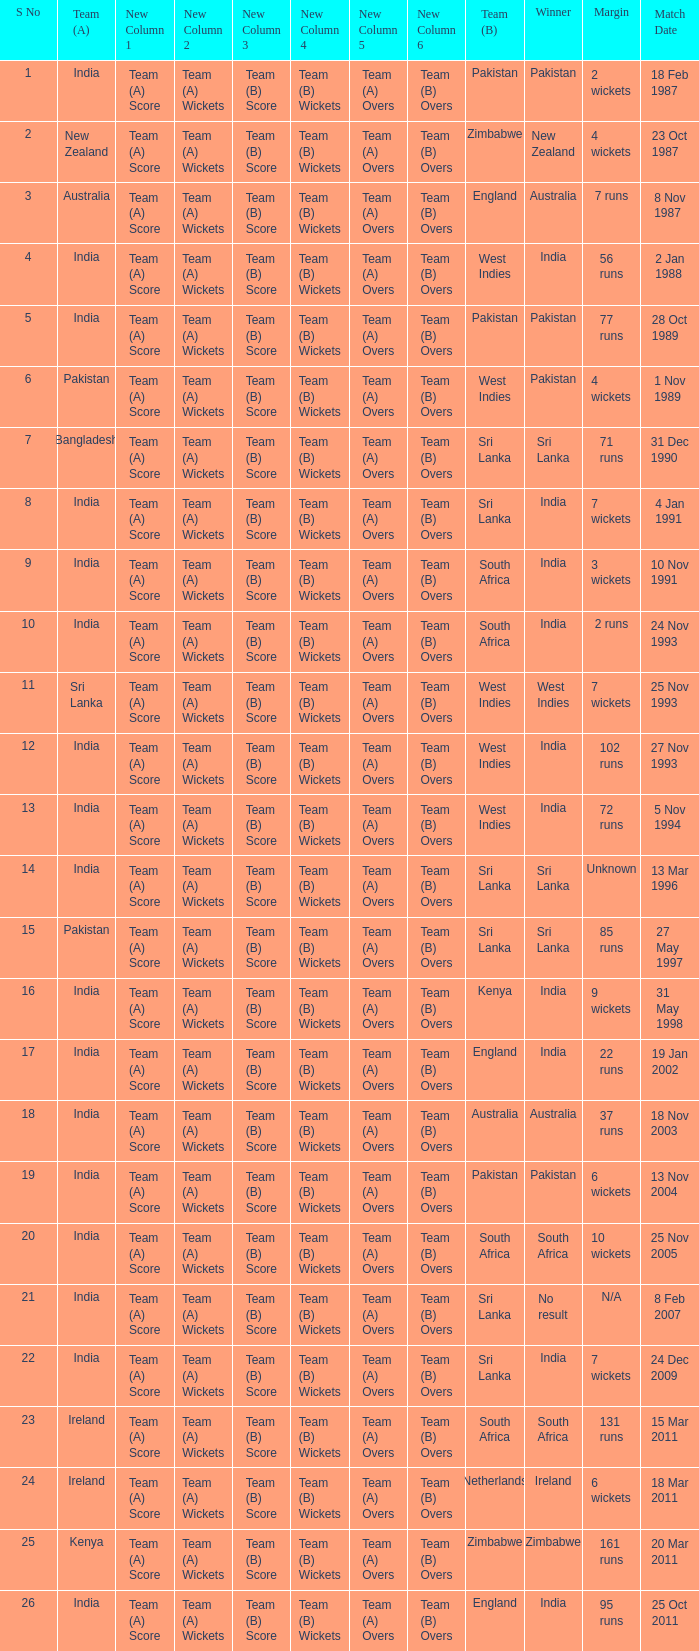What was the margin of the match on 19 Jan 2002? 22 runs. 